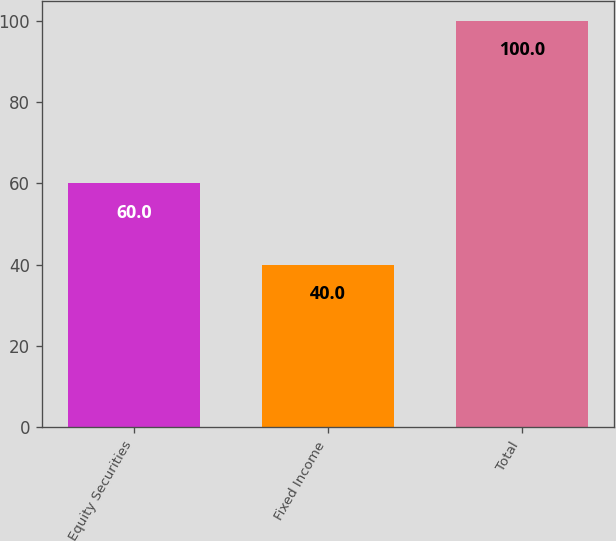Convert chart to OTSL. <chart><loc_0><loc_0><loc_500><loc_500><bar_chart><fcel>Equity Securities<fcel>Fixed Income<fcel>Total<nl><fcel>60<fcel>40<fcel>100<nl></chart> 